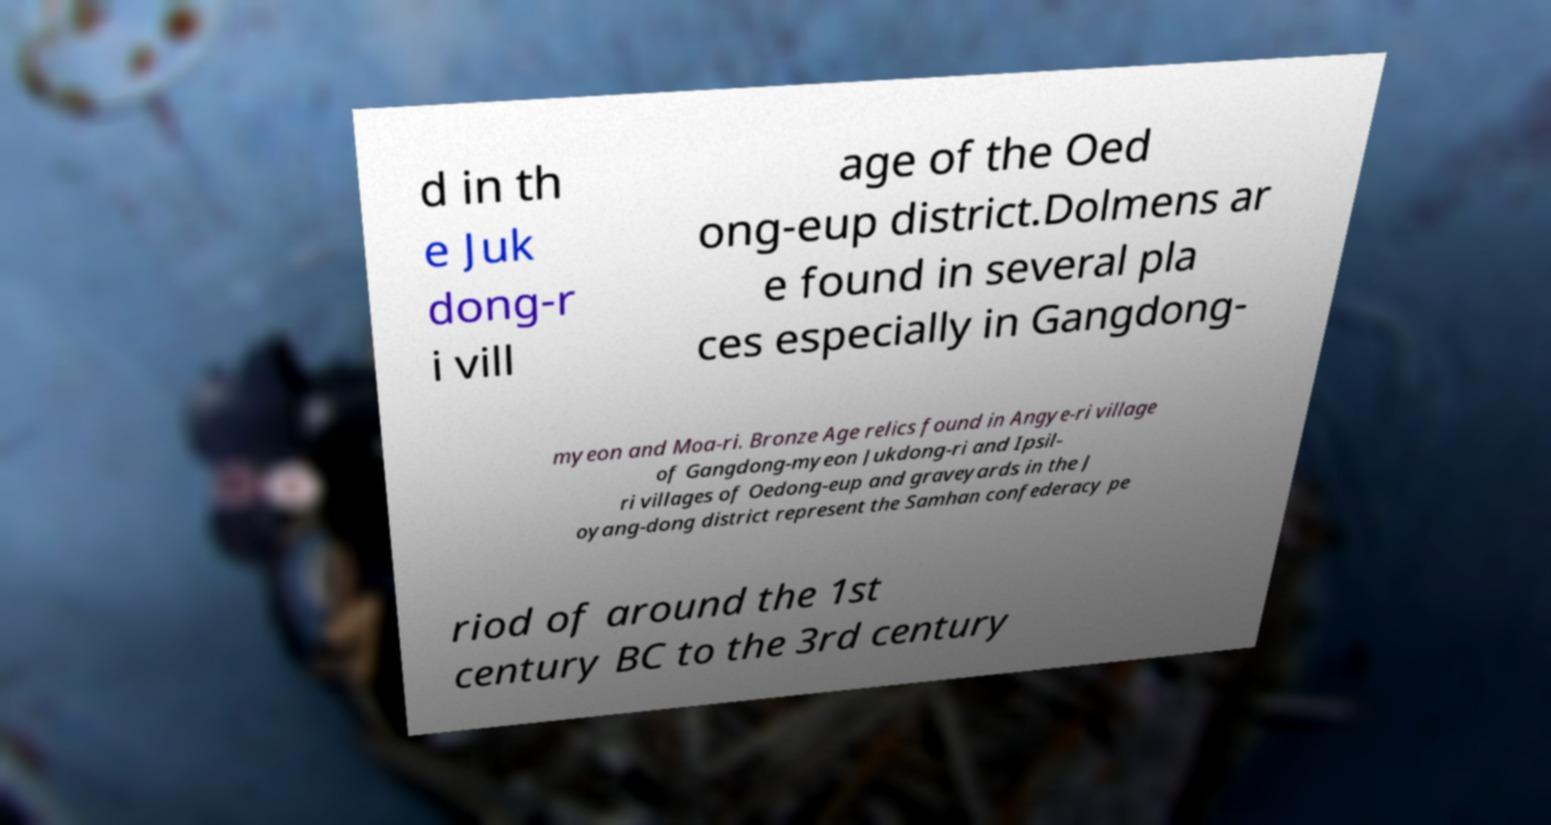Please identify and transcribe the text found in this image. d in th e Juk dong-r i vill age of the Oed ong-eup district.Dolmens ar e found in several pla ces especially in Gangdong- myeon and Moa-ri. Bronze Age relics found in Angye-ri village of Gangdong-myeon Jukdong-ri and Ipsil- ri villages of Oedong-eup and graveyards in the J oyang-dong district represent the Samhan confederacy pe riod of around the 1st century BC to the 3rd century 